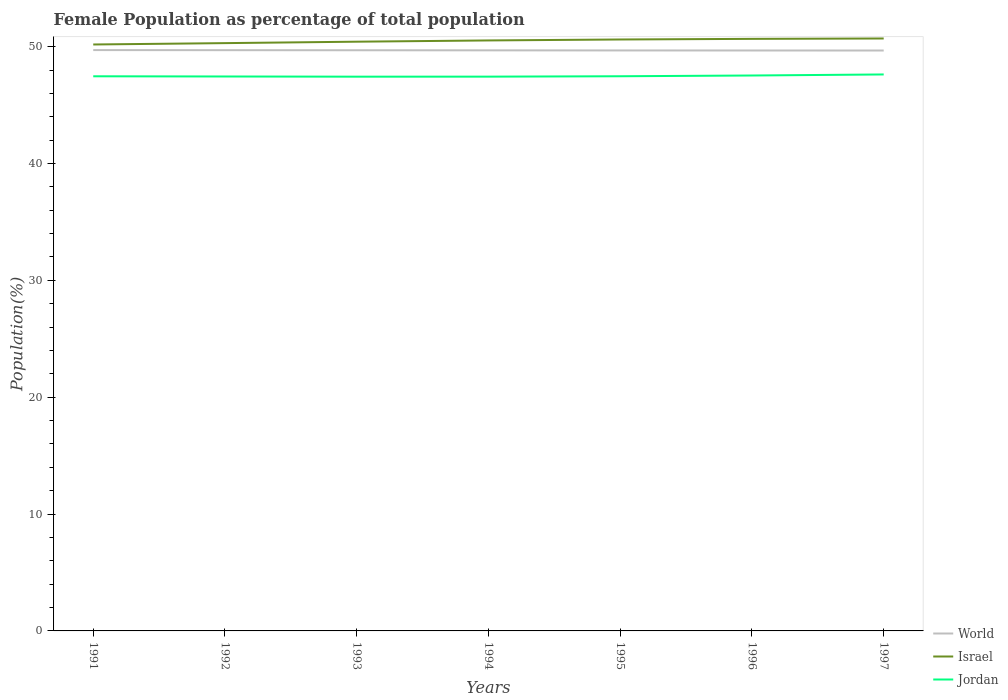Does the line corresponding to Jordan intersect with the line corresponding to World?
Provide a succinct answer. No. Across all years, what is the maximum female population in in World?
Offer a terse response. 49.67. In which year was the female population in in World maximum?
Ensure brevity in your answer.  1997. What is the total female population in in Jordan in the graph?
Ensure brevity in your answer.  -0.03. What is the difference between the highest and the second highest female population in in Israel?
Give a very brief answer. 0.51. Is the female population in in Israel strictly greater than the female population in in World over the years?
Provide a short and direct response. No. How many lines are there?
Offer a very short reply. 3. How many legend labels are there?
Make the answer very short. 3. What is the title of the graph?
Ensure brevity in your answer.  Female Population as percentage of total population. Does "Chile" appear as one of the legend labels in the graph?
Make the answer very short. No. What is the label or title of the Y-axis?
Provide a short and direct response. Population(%). What is the Population(%) in World in 1991?
Make the answer very short. 49.71. What is the Population(%) in Israel in 1991?
Provide a short and direct response. 50.18. What is the Population(%) in Jordan in 1991?
Your answer should be compact. 47.46. What is the Population(%) of World in 1992?
Give a very brief answer. 49.7. What is the Population(%) in Israel in 1992?
Your answer should be very brief. 50.3. What is the Population(%) in Jordan in 1992?
Provide a short and direct response. 47.45. What is the Population(%) in World in 1993?
Provide a succinct answer. 49.69. What is the Population(%) in Israel in 1993?
Provide a short and direct response. 50.42. What is the Population(%) in Jordan in 1993?
Offer a terse response. 47.43. What is the Population(%) in World in 1994?
Offer a terse response. 49.68. What is the Population(%) of Israel in 1994?
Offer a very short reply. 50.53. What is the Population(%) in Jordan in 1994?
Your answer should be compact. 47.43. What is the Population(%) of World in 1995?
Make the answer very short. 49.67. What is the Population(%) of Israel in 1995?
Your response must be concise. 50.61. What is the Population(%) in Jordan in 1995?
Ensure brevity in your answer.  47.47. What is the Population(%) in World in 1996?
Your response must be concise. 49.67. What is the Population(%) of Israel in 1996?
Keep it short and to the point. 50.67. What is the Population(%) in Jordan in 1996?
Offer a very short reply. 47.53. What is the Population(%) of World in 1997?
Offer a very short reply. 49.67. What is the Population(%) of Israel in 1997?
Ensure brevity in your answer.  50.7. What is the Population(%) in Jordan in 1997?
Give a very brief answer. 47.62. Across all years, what is the maximum Population(%) in World?
Give a very brief answer. 49.71. Across all years, what is the maximum Population(%) in Israel?
Your answer should be compact. 50.7. Across all years, what is the maximum Population(%) in Jordan?
Provide a short and direct response. 47.62. Across all years, what is the minimum Population(%) of World?
Keep it short and to the point. 49.67. Across all years, what is the minimum Population(%) in Israel?
Your answer should be compact. 50.18. Across all years, what is the minimum Population(%) of Jordan?
Your answer should be compact. 47.43. What is the total Population(%) in World in the graph?
Your answer should be very brief. 347.79. What is the total Population(%) of Israel in the graph?
Give a very brief answer. 353.41. What is the total Population(%) in Jordan in the graph?
Provide a short and direct response. 332.38. What is the difference between the Population(%) of World in 1991 and that in 1992?
Provide a succinct answer. 0.01. What is the difference between the Population(%) of Israel in 1991 and that in 1992?
Your response must be concise. -0.12. What is the difference between the Population(%) in Jordan in 1991 and that in 1992?
Your response must be concise. 0.02. What is the difference between the Population(%) of World in 1991 and that in 1993?
Give a very brief answer. 0.02. What is the difference between the Population(%) in Israel in 1991 and that in 1993?
Make the answer very short. -0.24. What is the difference between the Population(%) in Jordan in 1991 and that in 1993?
Keep it short and to the point. 0.03. What is the difference between the Population(%) of World in 1991 and that in 1994?
Provide a short and direct response. 0.02. What is the difference between the Population(%) of Israel in 1991 and that in 1994?
Keep it short and to the point. -0.35. What is the difference between the Population(%) of Jordan in 1991 and that in 1994?
Offer a terse response. 0.03. What is the difference between the Population(%) in World in 1991 and that in 1995?
Your response must be concise. 0.03. What is the difference between the Population(%) in Israel in 1991 and that in 1995?
Provide a short and direct response. -0.43. What is the difference between the Population(%) in Jordan in 1991 and that in 1995?
Your response must be concise. -0. What is the difference between the Population(%) in World in 1991 and that in 1996?
Your answer should be very brief. 0.04. What is the difference between the Population(%) of Israel in 1991 and that in 1996?
Offer a very short reply. -0.48. What is the difference between the Population(%) in Jordan in 1991 and that in 1996?
Offer a very short reply. -0.07. What is the difference between the Population(%) of World in 1991 and that in 1997?
Keep it short and to the point. 0.04. What is the difference between the Population(%) of Israel in 1991 and that in 1997?
Offer a terse response. -0.51. What is the difference between the Population(%) in Jordan in 1991 and that in 1997?
Offer a very short reply. -0.16. What is the difference between the Population(%) of World in 1992 and that in 1993?
Your response must be concise. 0.01. What is the difference between the Population(%) of Israel in 1992 and that in 1993?
Ensure brevity in your answer.  -0.12. What is the difference between the Population(%) in Jordan in 1992 and that in 1993?
Your answer should be compact. 0.02. What is the difference between the Population(%) of World in 1992 and that in 1994?
Offer a very short reply. 0.02. What is the difference between the Population(%) of Israel in 1992 and that in 1994?
Keep it short and to the point. -0.23. What is the difference between the Population(%) in Jordan in 1992 and that in 1994?
Offer a very short reply. 0.01. What is the difference between the Population(%) in World in 1992 and that in 1995?
Make the answer very short. 0.02. What is the difference between the Population(%) in Israel in 1992 and that in 1995?
Offer a terse response. -0.31. What is the difference between the Population(%) of Jordan in 1992 and that in 1995?
Offer a terse response. -0.02. What is the difference between the Population(%) in World in 1992 and that in 1996?
Provide a succinct answer. 0.03. What is the difference between the Population(%) of Israel in 1992 and that in 1996?
Provide a short and direct response. -0.36. What is the difference between the Population(%) of Jordan in 1992 and that in 1996?
Offer a very short reply. -0.08. What is the difference between the Population(%) of World in 1992 and that in 1997?
Give a very brief answer. 0.03. What is the difference between the Population(%) of Israel in 1992 and that in 1997?
Offer a terse response. -0.4. What is the difference between the Population(%) of Jordan in 1992 and that in 1997?
Offer a terse response. -0.17. What is the difference between the Population(%) in World in 1993 and that in 1994?
Offer a terse response. 0.01. What is the difference between the Population(%) in Israel in 1993 and that in 1994?
Provide a short and direct response. -0.11. What is the difference between the Population(%) of Jordan in 1993 and that in 1994?
Provide a succinct answer. -0. What is the difference between the Population(%) in World in 1993 and that in 1995?
Provide a succinct answer. 0.02. What is the difference between the Population(%) in Israel in 1993 and that in 1995?
Provide a short and direct response. -0.19. What is the difference between the Population(%) of Jordan in 1993 and that in 1995?
Your answer should be compact. -0.04. What is the difference between the Population(%) in World in 1993 and that in 1996?
Ensure brevity in your answer.  0.02. What is the difference between the Population(%) of Israel in 1993 and that in 1996?
Provide a succinct answer. -0.24. What is the difference between the Population(%) in Jordan in 1993 and that in 1996?
Your response must be concise. -0.1. What is the difference between the Population(%) of World in 1993 and that in 1997?
Keep it short and to the point. 0.02. What is the difference between the Population(%) of Israel in 1993 and that in 1997?
Keep it short and to the point. -0.27. What is the difference between the Population(%) in Jordan in 1993 and that in 1997?
Your answer should be very brief. -0.19. What is the difference between the Population(%) in World in 1994 and that in 1995?
Your answer should be very brief. 0.01. What is the difference between the Population(%) of Israel in 1994 and that in 1995?
Offer a very short reply. -0.08. What is the difference between the Population(%) in Jordan in 1994 and that in 1995?
Give a very brief answer. -0.03. What is the difference between the Population(%) in World in 1994 and that in 1996?
Keep it short and to the point. 0.01. What is the difference between the Population(%) in Israel in 1994 and that in 1996?
Ensure brevity in your answer.  -0.14. What is the difference between the Population(%) in Jordan in 1994 and that in 1996?
Your response must be concise. -0.1. What is the difference between the Population(%) of World in 1994 and that in 1997?
Your answer should be very brief. 0.02. What is the difference between the Population(%) of Israel in 1994 and that in 1997?
Provide a succinct answer. -0.17. What is the difference between the Population(%) in Jordan in 1994 and that in 1997?
Keep it short and to the point. -0.19. What is the difference between the Population(%) in World in 1995 and that in 1996?
Provide a short and direct response. 0. What is the difference between the Population(%) of Israel in 1995 and that in 1996?
Give a very brief answer. -0.05. What is the difference between the Population(%) of Jordan in 1995 and that in 1996?
Your answer should be very brief. -0.06. What is the difference between the Population(%) in World in 1995 and that in 1997?
Make the answer very short. 0.01. What is the difference between the Population(%) in Israel in 1995 and that in 1997?
Offer a terse response. -0.09. What is the difference between the Population(%) in Jordan in 1995 and that in 1997?
Ensure brevity in your answer.  -0.15. What is the difference between the Population(%) of World in 1996 and that in 1997?
Make the answer very short. 0. What is the difference between the Population(%) in Israel in 1996 and that in 1997?
Your answer should be very brief. -0.03. What is the difference between the Population(%) in Jordan in 1996 and that in 1997?
Provide a succinct answer. -0.09. What is the difference between the Population(%) in World in 1991 and the Population(%) in Israel in 1992?
Ensure brevity in your answer.  -0.6. What is the difference between the Population(%) in World in 1991 and the Population(%) in Jordan in 1992?
Your answer should be very brief. 2.26. What is the difference between the Population(%) of Israel in 1991 and the Population(%) of Jordan in 1992?
Your answer should be compact. 2.74. What is the difference between the Population(%) in World in 1991 and the Population(%) in Israel in 1993?
Make the answer very short. -0.72. What is the difference between the Population(%) of World in 1991 and the Population(%) of Jordan in 1993?
Ensure brevity in your answer.  2.28. What is the difference between the Population(%) in Israel in 1991 and the Population(%) in Jordan in 1993?
Provide a succinct answer. 2.76. What is the difference between the Population(%) of World in 1991 and the Population(%) of Israel in 1994?
Make the answer very short. -0.82. What is the difference between the Population(%) of World in 1991 and the Population(%) of Jordan in 1994?
Your answer should be compact. 2.27. What is the difference between the Population(%) of Israel in 1991 and the Population(%) of Jordan in 1994?
Ensure brevity in your answer.  2.75. What is the difference between the Population(%) of World in 1991 and the Population(%) of Israel in 1995?
Your answer should be compact. -0.91. What is the difference between the Population(%) of World in 1991 and the Population(%) of Jordan in 1995?
Provide a succinct answer. 2.24. What is the difference between the Population(%) of Israel in 1991 and the Population(%) of Jordan in 1995?
Offer a very short reply. 2.72. What is the difference between the Population(%) of World in 1991 and the Population(%) of Israel in 1996?
Offer a terse response. -0.96. What is the difference between the Population(%) of World in 1991 and the Population(%) of Jordan in 1996?
Ensure brevity in your answer.  2.18. What is the difference between the Population(%) of Israel in 1991 and the Population(%) of Jordan in 1996?
Provide a succinct answer. 2.65. What is the difference between the Population(%) of World in 1991 and the Population(%) of Israel in 1997?
Your response must be concise. -0.99. What is the difference between the Population(%) of World in 1991 and the Population(%) of Jordan in 1997?
Keep it short and to the point. 2.09. What is the difference between the Population(%) in Israel in 1991 and the Population(%) in Jordan in 1997?
Your answer should be very brief. 2.56. What is the difference between the Population(%) of World in 1992 and the Population(%) of Israel in 1993?
Your answer should be very brief. -0.72. What is the difference between the Population(%) of World in 1992 and the Population(%) of Jordan in 1993?
Your answer should be compact. 2.27. What is the difference between the Population(%) in Israel in 1992 and the Population(%) in Jordan in 1993?
Your response must be concise. 2.87. What is the difference between the Population(%) of World in 1992 and the Population(%) of Israel in 1994?
Ensure brevity in your answer.  -0.83. What is the difference between the Population(%) of World in 1992 and the Population(%) of Jordan in 1994?
Your answer should be compact. 2.27. What is the difference between the Population(%) of Israel in 1992 and the Population(%) of Jordan in 1994?
Your response must be concise. 2.87. What is the difference between the Population(%) of World in 1992 and the Population(%) of Israel in 1995?
Provide a short and direct response. -0.91. What is the difference between the Population(%) in World in 1992 and the Population(%) in Jordan in 1995?
Give a very brief answer. 2.23. What is the difference between the Population(%) of Israel in 1992 and the Population(%) of Jordan in 1995?
Keep it short and to the point. 2.84. What is the difference between the Population(%) in World in 1992 and the Population(%) in Israel in 1996?
Keep it short and to the point. -0.97. What is the difference between the Population(%) of World in 1992 and the Population(%) of Jordan in 1996?
Your answer should be very brief. 2.17. What is the difference between the Population(%) of Israel in 1992 and the Population(%) of Jordan in 1996?
Provide a short and direct response. 2.77. What is the difference between the Population(%) of World in 1992 and the Population(%) of Israel in 1997?
Make the answer very short. -1. What is the difference between the Population(%) in World in 1992 and the Population(%) in Jordan in 1997?
Offer a very short reply. 2.08. What is the difference between the Population(%) of Israel in 1992 and the Population(%) of Jordan in 1997?
Provide a short and direct response. 2.68. What is the difference between the Population(%) of World in 1993 and the Population(%) of Israel in 1994?
Your response must be concise. -0.84. What is the difference between the Population(%) of World in 1993 and the Population(%) of Jordan in 1994?
Provide a succinct answer. 2.26. What is the difference between the Population(%) in Israel in 1993 and the Population(%) in Jordan in 1994?
Make the answer very short. 2.99. What is the difference between the Population(%) in World in 1993 and the Population(%) in Israel in 1995?
Keep it short and to the point. -0.92. What is the difference between the Population(%) in World in 1993 and the Population(%) in Jordan in 1995?
Offer a terse response. 2.22. What is the difference between the Population(%) of Israel in 1993 and the Population(%) of Jordan in 1995?
Ensure brevity in your answer.  2.96. What is the difference between the Population(%) in World in 1993 and the Population(%) in Israel in 1996?
Make the answer very short. -0.98. What is the difference between the Population(%) in World in 1993 and the Population(%) in Jordan in 1996?
Provide a short and direct response. 2.16. What is the difference between the Population(%) in Israel in 1993 and the Population(%) in Jordan in 1996?
Your answer should be compact. 2.89. What is the difference between the Population(%) of World in 1993 and the Population(%) of Israel in 1997?
Offer a very short reply. -1.01. What is the difference between the Population(%) of World in 1993 and the Population(%) of Jordan in 1997?
Offer a very short reply. 2.07. What is the difference between the Population(%) in Israel in 1993 and the Population(%) in Jordan in 1997?
Your answer should be compact. 2.8. What is the difference between the Population(%) of World in 1994 and the Population(%) of Israel in 1995?
Your answer should be very brief. -0.93. What is the difference between the Population(%) of World in 1994 and the Population(%) of Jordan in 1995?
Give a very brief answer. 2.22. What is the difference between the Population(%) in Israel in 1994 and the Population(%) in Jordan in 1995?
Your answer should be compact. 3.06. What is the difference between the Population(%) of World in 1994 and the Population(%) of Israel in 1996?
Offer a very short reply. -0.98. What is the difference between the Population(%) of World in 1994 and the Population(%) of Jordan in 1996?
Ensure brevity in your answer.  2.15. What is the difference between the Population(%) of Israel in 1994 and the Population(%) of Jordan in 1996?
Offer a terse response. 3. What is the difference between the Population(%) in World in 1994 and the Population(%) in Israel in 1997?
Keep it short and to the point. -1.01. What is the difference between the Population(%) of World in 1994 and the Population(%) of Jordan in 1997?
Give a very brief answer. 2.06. What is the difference between the Population(%) of Israel in 1994 and the Population(%) of Jordan in 1997?
Keep it short and to the point. 2.91. What is the difference between the Population(%) in World in 1995 and the Population(%) in Israel in 1996?
Provide a succinct answer. -0.99. What is the difference between the Population(%) in World in 1995 and the Population(%) in Jordan in 1996?
Provide a short and direct response. 2.14. What is the difference between the Population(%) in Israel in 1995 and the Population(%) in Jordan in 1996?
Provide a succinct answer. 3.08. What is the difference between the Population(%) in World in 1995 and the Population(%) in Israel in 1997?
Your answer should be compact. -1.02. What is the difference between the Population(%) of World in 1995 and the Population(%) of Jordan in 1997?
Provide a succinct answer. 2.06. What is the difference between the Population(%) in Israel in 1995 and the Population(%) in Jordan in 1997?
Your response must be concise. 2.99. What is the difference between the Population(%) in World in 1996 and the Population(%) in Israel in 1997?
Your answer should be compact. -1.03. What is the difference between the Population(%) of World in 1996 and the Population(%) of Jordan in 1997?
Provide a short and direct response. 2.05. What is the difference between the Population(%) in Israel in 1996 and the Population(%) in Jordan in 1997?
Give a very brief answer. 3.05. What is the average Population(%) of World per year?
Your answer should be very brief. 49.68. What is the average Population(%) of Israel per year?
Make the answer very short. 50.49. What is the average Population(%) in Jordan per year?
Offer a very short reply. 47.48. In the year 1991, what is the difference between the Population(%) of World and Population(%) of Israel?
Provide a succinct answer. -0.48. In the year 1991, what is the difference between the Population(%) in World and Population(%) in Jordan?
Provide a succinct answer. 2.24. In the year 1991, what is the difference between the Population(%) in Israel and Population(%) in Jordan?
Your response must be concise. 2.72. In the year 1992, what is the difference between the Population(%) in World and Population(%) in Israel?
Provide a succinct answer. -0.6. In the year 1992, what is the difference between the Population(%) in World and Population(%) in Jordan?
Your answer should be very brief. 2.25. In the year 1992, what is the difference between the Population(%) in Israel and Population(%) in Jordan?
Offer a very short reply. 2.86. In the year 1993, what is the difference between the Population(%) in World and Population(%) in Israel?
Provide a short and direct response. -0.73. In the year 1993, what is the difference between the Population(%) of World and Population(%) of Jordan?
Offer a very short reply. 2.26. In the year 1993, what is the difference between the Population(%) in Israel and Population(%) in Jordan?
Provide a short and direct response. 2.99. In the year 1994, what is the difference between the Population(%) of World and Population(%) of Israel?
Your response must be concise. -0.85. In the year 1994, what is the difference between the Population(%) in World and Population(%) in Jordan?
Keep it short and to the point. 2.25. In the year 1994, what is the difference between the Population(%) in Israel and Population(%) in Jordan?
Provide a succinct answer. 3.1. In the year 1995, what is the difference between the Population(%) of World and Population(%) of Israel?
Make the answer very short. -0.94. In the year 1995, what is the difference between the Population(%) in World and Population(%) in Jordan?
Your answer should be very brief. 2.21. In the year 1995, what is the difference between the Population(%) in Israel and Population(%) in Jordan?
Your response must be concise. 3.15. In the year 1996, what is the difference between the Population(%) in World and Population(%) in Israel?
Give a very brief answer. -0.99. In the year 1996, what is the difference between the Population(%) of World and Population(%) of Jordan?
Make the answer very short. 2.14. In the year 1996, what is the difference between the Population(%) of Israel and Population(%) of Jordan?
Your response must be concise. 3.14. In the year 1997, what is the difference between the Population(%) of World and Population(%) of Israel?
Give a very brief answer. -1.03. In the year 1997, what is the difference between the Population(%) in World and Population(%) in Jordan?
Make the answer very short. 2.05. In the year 1997, what is the difference between the Population(%) of Israel and Population(%) of Jordan?
Ensure brevity in your answer.  3.08. What is the ratio of the Population(%) of Israel in 1991 to that in 1992?
Your answer should be very brief. 1. What is the ratio of the Population(%) of World in 1991 to that in 1993?
Provide a succinct answer. 1. What is the ratio of the Population(%) of Jordan in 1991 to that in 1993?
Your answer should be compact. 1. What is the ratio of the Population(%) in World in 1991 to that in 1994?
Provide a succinct answer. 1. What is the ratio of the Population(%) of Jordan in 1991 to that in 1994?
Make the answer very short. 1. What is the ratio of the Population(%) of Jordan in 1991 to that in 1995?
Offer a terse response. 1. What is the ratio of the Population(%) in Israel in 1991 to that in 1996?
Offer a terse response. 0.99. What is the ratio of the Population(%) in Israel in 1991 to that in 1997?
Make the answer very short. 0.99. What is the ratio of the Population(%) of Jordan in 1991 to that in 1997?
Your response must be concise. 1. What is the ratio of the Population(%) of World in 1992 to that in 1993?
Keep it short and to the point. 1. What is the ratio of the Population(%) of Israel in 1992 to that in 1994?
Provide a succinct answer. 1. What is the ratio of the Population(%) in Israel in 1992 to that in 1995?
Offer a terse response. 0.99. What is the ratio of the Population(%) in Jordan in 1992 to that in 1995?
Keep it short and to the point. 1. What is the ratio of the Population(%) in World in 1992 to that in 1996?
Offer a terse response. 1. What is the ratio of the Population(%) in Israel in 1992 to that in 1996?
Provide a succinct answer. 0.99. What is the ratio of the Population(%) of Israel in 1992 to that in 1997?
Make the answer very short. 0.99. What is the ratio of the Population(%) in Jordan in 1992 to that in 1997?
Offer a very short reply. 1. What is the ratio of the Population(%) of World in 1993 to that in 1994?
Make the answer very short. 1. What is the ratio of the Population(%) in Israel in 1993 to that in 1994?
Offer a terse response. 1. What is the ratio of the Population(%) in Jordan in 1993 to that in 1994?
Provide a short and direct response. 1. What is the ratio of the Population(%) of Israel in 1993 to that in 1996?
Your answer should be compact. 1. What is the ratio of the Population(%) in Jordan in 1993 to that in 1996?
Provide a short and direct response. 1. What is the ratio of the Population(%) of World in 1993 to that in 1997?
Give a very brief answer. 1. What is the ratio of the Population(%) of Israel in 1993 to that in 1997?
Offer a very short reply. 0.99. What is the ratio of the Population(%) in Jordan in 1993 to that in 1997?
Ensure brevity in your answer.  1. What is the ratio of the Population(%) of World in 1994 to that in 1995?
Your response must be concise. 1. What is the ratio of the Population(%) in Israel in 1994 to that in 1995?
Provide a succinct answer. 1. What is the ratio of the Population(%) of Jordan in 1994 to that in 1995?
Your answer should be compact. 1. What is the ratio of the Population(%) of Israel in 1994 to that in 1996?
Give a very brief answer. 1. What is the ratio of the Population(%) of Jordan in 1995 to that in 1996?
Provide a short and direct response. 1. What is the ratio of the Population(%) of World in 1995 to that in 1997?
Provide a succinct answer. 1. What is the ratio of the Population(%) in Jordan in 1995 to that in 1997?
Give a very brief answer. 1. What is the ratio of the Population(%) of Jordan in 1996 to that in 1997?
Make the answer very short. 1. What is the difference between the highest and the second highest Population(%) of World?
Keep it short and to the point. 0.01. What is the difference between the highest and the second highest Population(%) of Israel?
Make the answer very short. 0.03. What is the difference between the highest and the second highest Population(%) of Jordan?
Your answer should be compact. 0.09. What is the difference between the highest and the lowest Population(%) of World?
Offer a terse response. 0.04. What is the difference between the highest and the lowest Population(%) of Israel?
Make the answer very short. 0.51. What is the difference between the highest and the lowest Population(%) of Jordan?
Offer a very short reply. 0.19. 